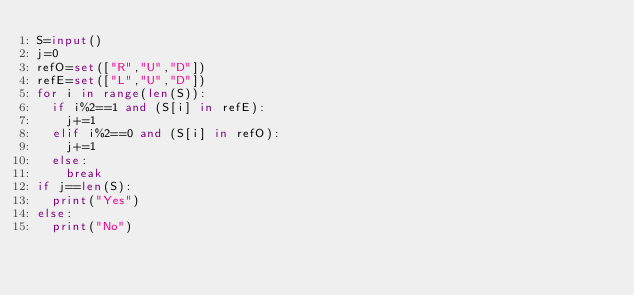Convert code to text. <code><loc_0><loc_0><loc_500><loc_500><_Python_>S=input()
j=0
refO=set(["R","U","D"])
refE=set(["L","U","D"])
for i in range(len(S)):
  if i%2==1 and (S[i] in refE):
    j+=1
  elif i%2==0 and (S[i] in refO):
    j+=1
  else:
    break
if j==len(S):
  print("Yes")
else:
  print("No")</code> 